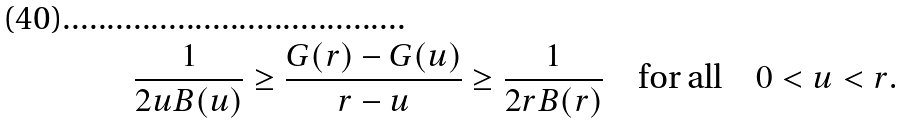Convert formula to latex. <formula><loc_0><loc_0><loc_500><loc_500>\frac { 1 } { 2 u B ( u ) } \geq \frac { G ( r ) - G ( u ) } { r - u } \geq \frac { 1 } { 2 r B ( r ) } \quad \text {for all} \quad 0 < u < r .</formula> 